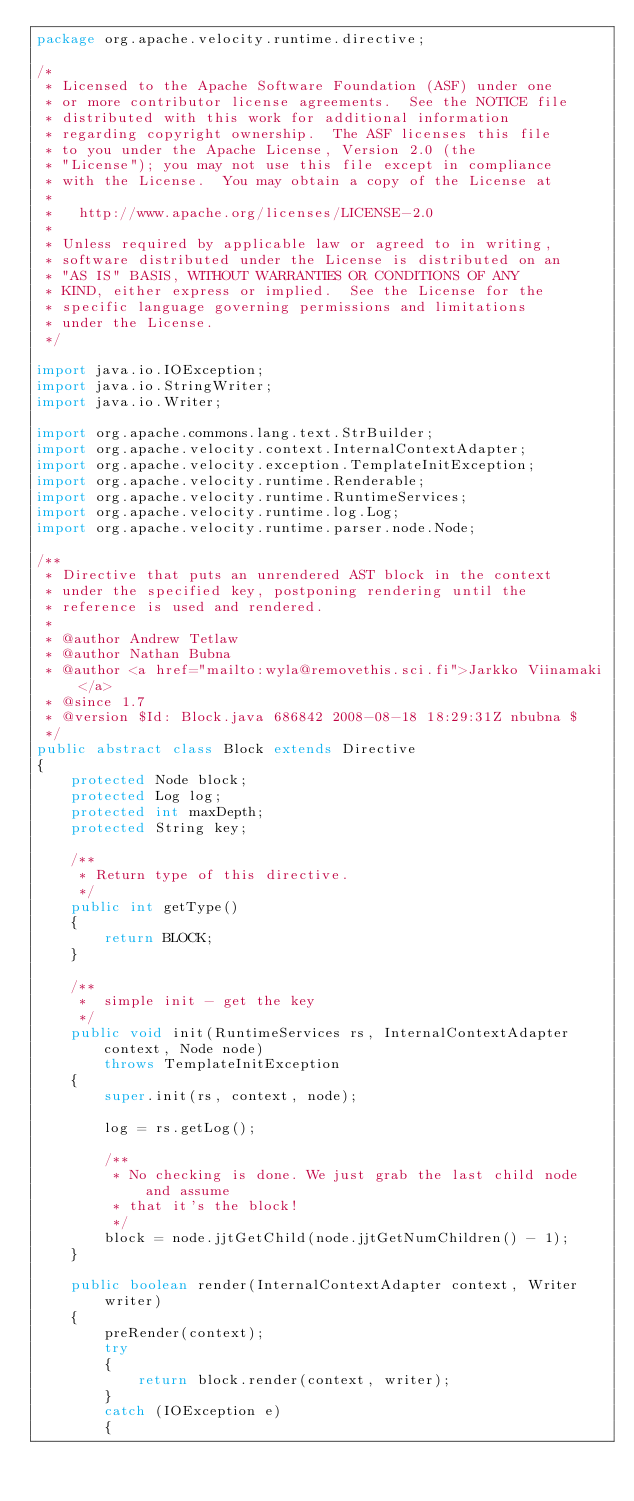<code> <loc_0><loc_0><loc_500><loc_500><_Java_>package org.apache.velocity.runtime.directive;

/*
 * Licensed to the Apache Software Foundation (ASF) under one
 * or more contributor license agreements.  See the NOTICE file
 * distributed with this work for additional information
 * regarding copyright ownership.  The ASF licenses this file
 * to you under the Apache License, Version 2.0 (the
 * "License"); you may not use this file except in compliance
 * with the License.  You may obtain a copy of the License at
 *
 *   http://www.apache.org/licenses/LICENSE-2.0
 *
 * Unless required by applicable law or agreed to in writing,
 * software distributed under the License is distributed on an
 * "AS IS" BASIS, WITHOUT WARRANTIES OR CONDITIONS OF ANY
 * KIND, either express or implied.  See the License for the
 * specific language governing permissions and limitations
 * under the License.    
 */

import java.io.IOException;
import java.io.StringWriter;
import java.io.Writer;

import org.apache.commons.lang.text.StrBuilder;
import org.apache.velocity.context.InternalContextAdapter;
import org.apache.velocity.exception.TemplateInitException;
import org.apache.velocity.runtime.Renderable;
import org.apache.velocity.runtime.RuntimeServices;
import org.apache.velocity.runtime.log.Log;
import org.apache.velocity.runtime.parser.node.Node;

/**
 * Directive that puts an unrendered AST block in the context
 * under the specified key, postponing rendering until the
 * reference is used and rendered.
 *
 * @author Andrew Tetlaw
 * @author Nathan Bubna
 * @author <a href="mailto:wyla@removethis.sci.fi">Jarkko Viinamaki</a>
 * @since 1.7
 * @version $Id: Block.java 686842 2008-08-18 18:29:31Z nbubna $
 */
public abstract class Block extends Directive
{
    protected Node block;
    protected Log log;
    protected int maxDepth;
    protected String key;

    /**
     * Return type of this directive.
     */
    public int getType()
    {
        return BLOCK;
    }

    /**
     *  simple init - get the key
     */
    public void init(RuntimeServices rs, InternalContextAdapter context, Node node)
        throws TemplateInitException
    {
        super.init(rs, context, node);

        log = rs.getLog();

        /**
         * No checking is done. We just grab the last child node and assume
         * that it's the block!
         */
        block = node.jjtGetChild(node.jjtGetNumChildren() - 1);
    }

    public boolean render(InternalContextAdapter context, Writer writer)
    {
        preRender(context);
        try
        {
            return block.render(context, writer);
        }
        catch (IOException e)
        {</code> 